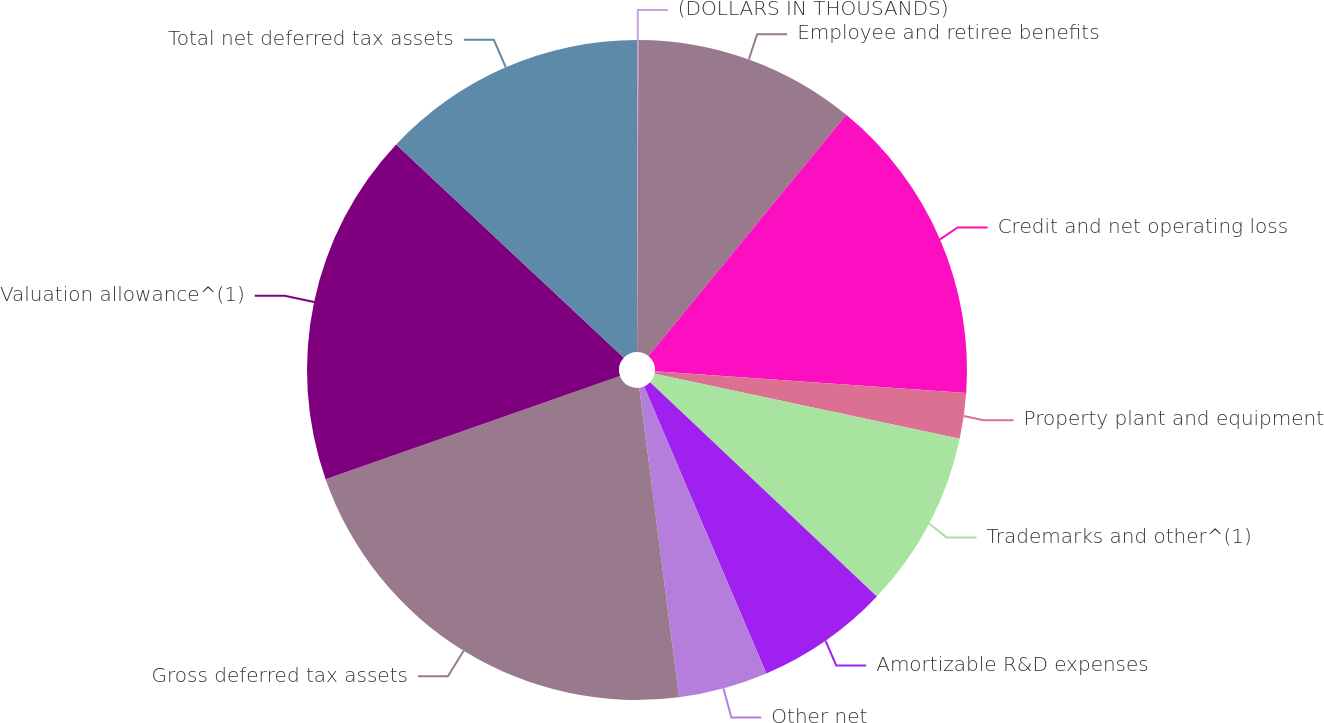Convert chart to OTSL. <chart><loc_0><loc_0><loc_500><loc_500><pie_chart><fcel>(DOLLARS IN THOUSANDS)<fcel>Employee and retiree benefits<fcel>Credit and net operating loss<fcel>Property plant and equipment<fcel>Trademarks and other^(1)<fcel>Amortizable R&D expenses<fcel>Other net<fcel>Gross deferred tax assets<fcel>Valuation allowance^(1)<fcel>Total net deferred tax assets<nl><fcel>0.07%<fcel>10.86%<fcel>15.18%<fcel>2.23%<fcel>8.7%<fcel>6.54%<fcel>4.38%<fcel>21.66%<fcel>17.34%<fcel>13.02%<nl></chart> 